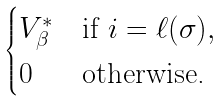<formula> <loc_0><loc_0><loc_500><loc_500>\begin{cases} V ^ { * } _ { \beta } & \text {if } i = \ell ( \sigma ) , \\ 0 & \text {otherwise.} \end{cases}</formula> 